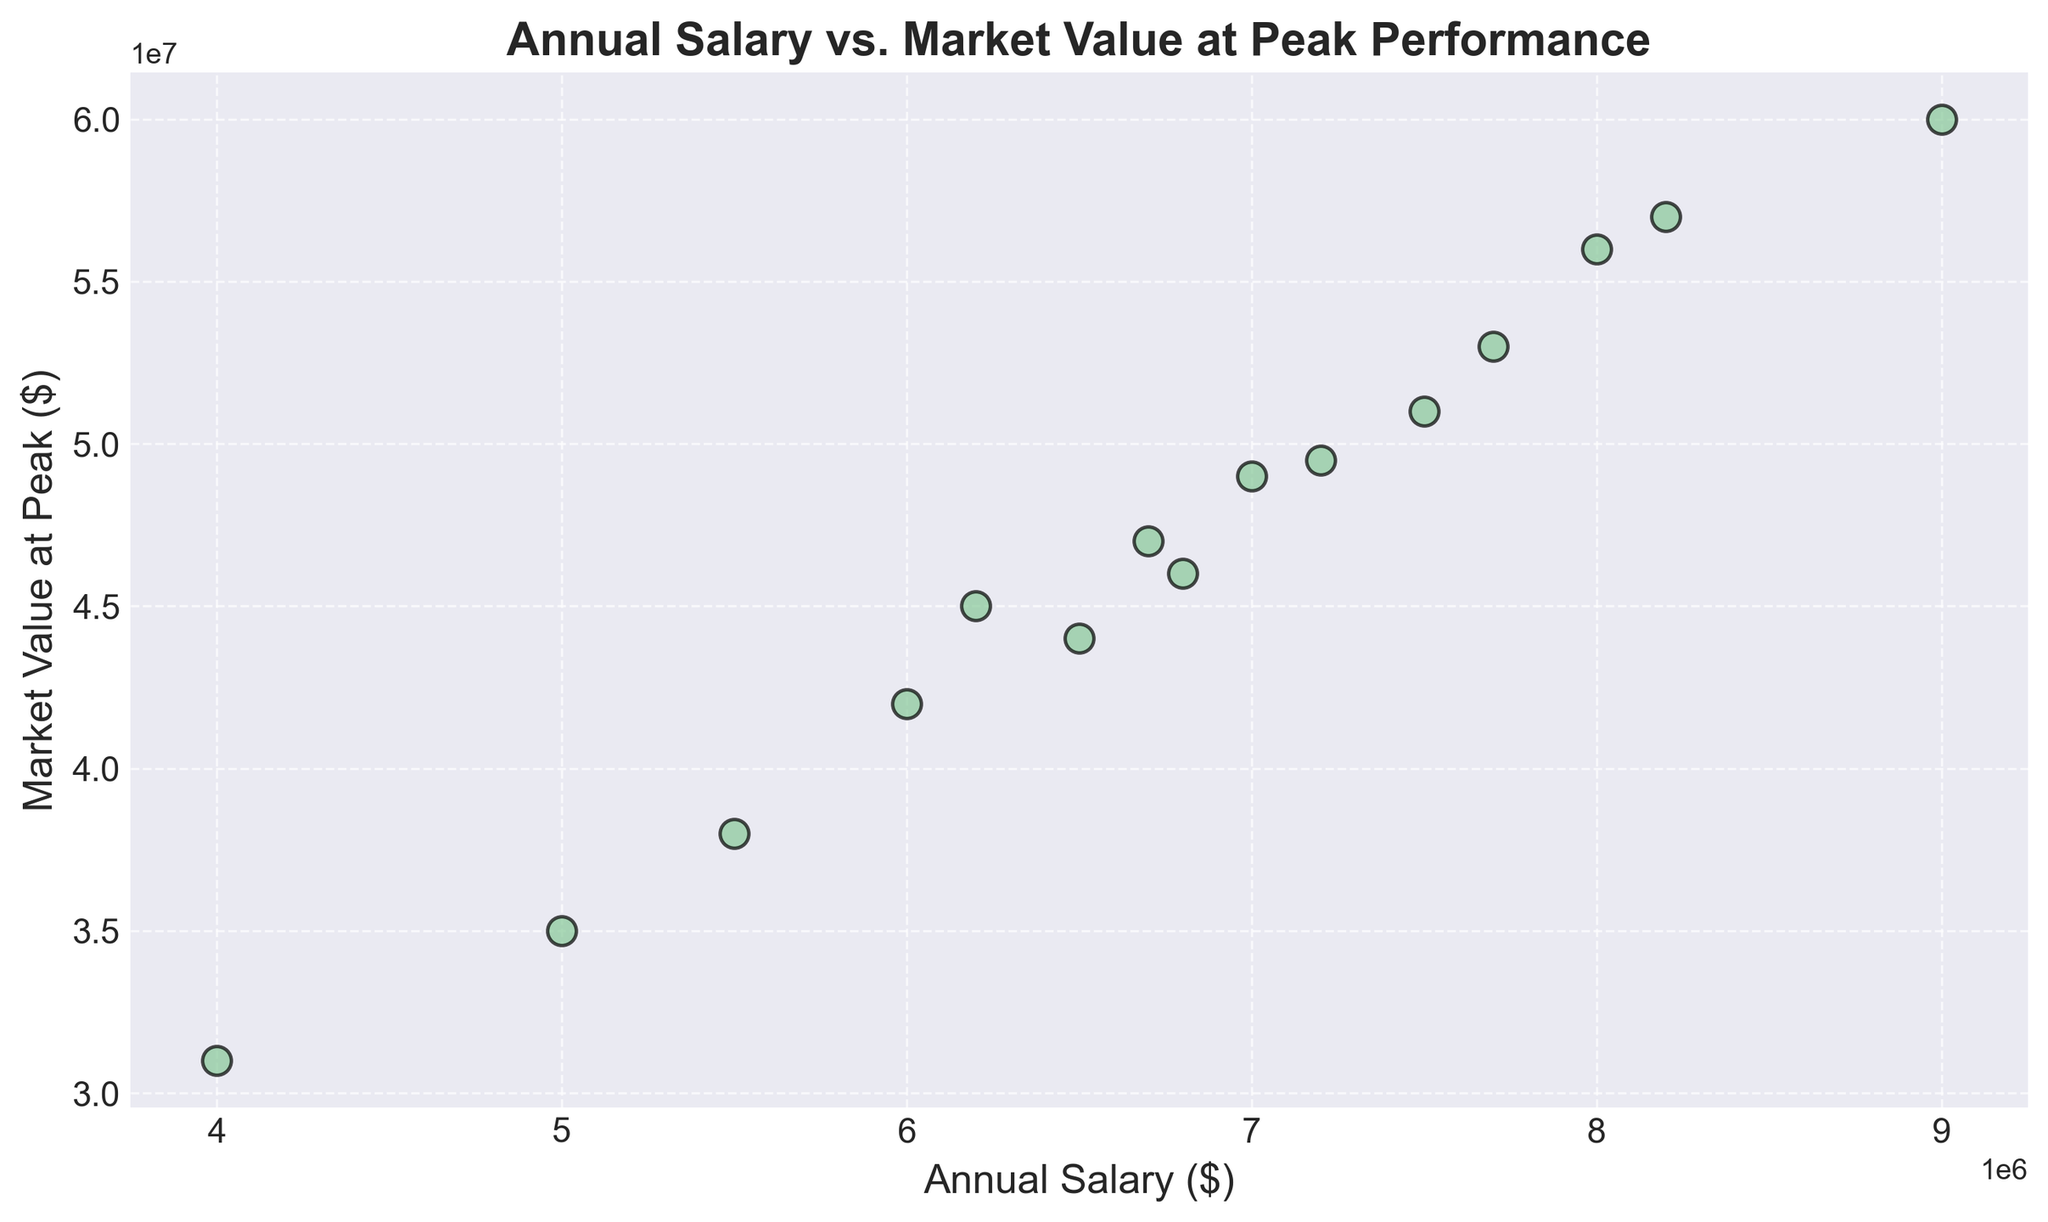What is the general trend observed between Annual Salary and Market Value at Peak Performance? The scatter plot shows that as the Annual Salary increases, the Market Value at Peak also tends to increase. The dots form an upward sloping pattern, indicating a positive relationship.
Answer: Positive relationship Which data point has the highest Market Value at Peak and what is its Annual Salary? Observing the y-axis, the highest Market Value at Peak is $60,000,000. Tracing it horizontally to the x-axis, its corresponding Annual Salary is $9,000,000.
Answer: $9,000,000 Find the average Annual Salary depicted in the plot. Adding all Annual Salary values (5,000,000 + 6,000,000 + 7,000,000 + 4,000,000 + 8,000,000 + 5,500,000 + 6,700,000 + 7,500,000 + 9,000,000 + 6,500,000 + 7,200,000 + 8,200,000 + 7,700,000 + 6,800,000 + 6,200,000) totals 101,300,000. Dividing by the number of players (15), the average Annual Salary is approximately $6,753,333.33.
Answer: $6,753,333.33 Are there any data points where the Annual Salary is lower, but the Market Value at Peak is similar or higher compared to others with higher salaries? Looking at the data point with an Annual Salary of $4,000,000 and Market Value at Peak of $31,000,000, it is close to and sometimes higher than those with higher salaries like $5,000,000 and $5,500,000 with Market Values of $35,000,000 and $38,000,000 respectively.
Answer: Yes What is the range of the Market Value at Peak Performance for the players depicted in the plot? The range is calculated by subtracting the smallest Market Value at Peak from the largest. The smallest value is $31,000,000 and the largest is $60,000,000. Therefore, the range is $60,000,000 - $31,000,000 = $29,000,000.
Answer: $29,000,000 Which data point has the lowest Annual Salary, and what is its corresponding Market Value at Peak? Observing the x-axis, the lowest Annual Salary is $4,000,000. Tracing it vertically to the y-axis, its corresponding Market Value at Peak Performance is $31,000,000.
Answer: $31,000,000 Between players with an Annual Salary of $7,200,000 and $6,800,000, which player has a higher Market Value at Peak Performance? Checking the plot, a player with an Annual Salary of $7,200,000 has a Market Value of $49,500,000, whereas the player with $6,800,000 has a Market Value of $46,000,000. Therefore, the player earning $7,200,000 has a higher Market Value at Peak.
Answer: $7,200,000 Calculate the difference in Market Value at Peak Performance between the players with the highest and lowest Annual Salaries. The player with the highest Annual Salary is earning $9,000,000, with a Market Value at Peak of $60,000,000. The lowest Annual Salary is $4,000,000, with a Market Value at Peak of $31,000,000. The difference is $60,000,000 - $31,000,000 = $29,000,000.
Answer: $29,000,000 